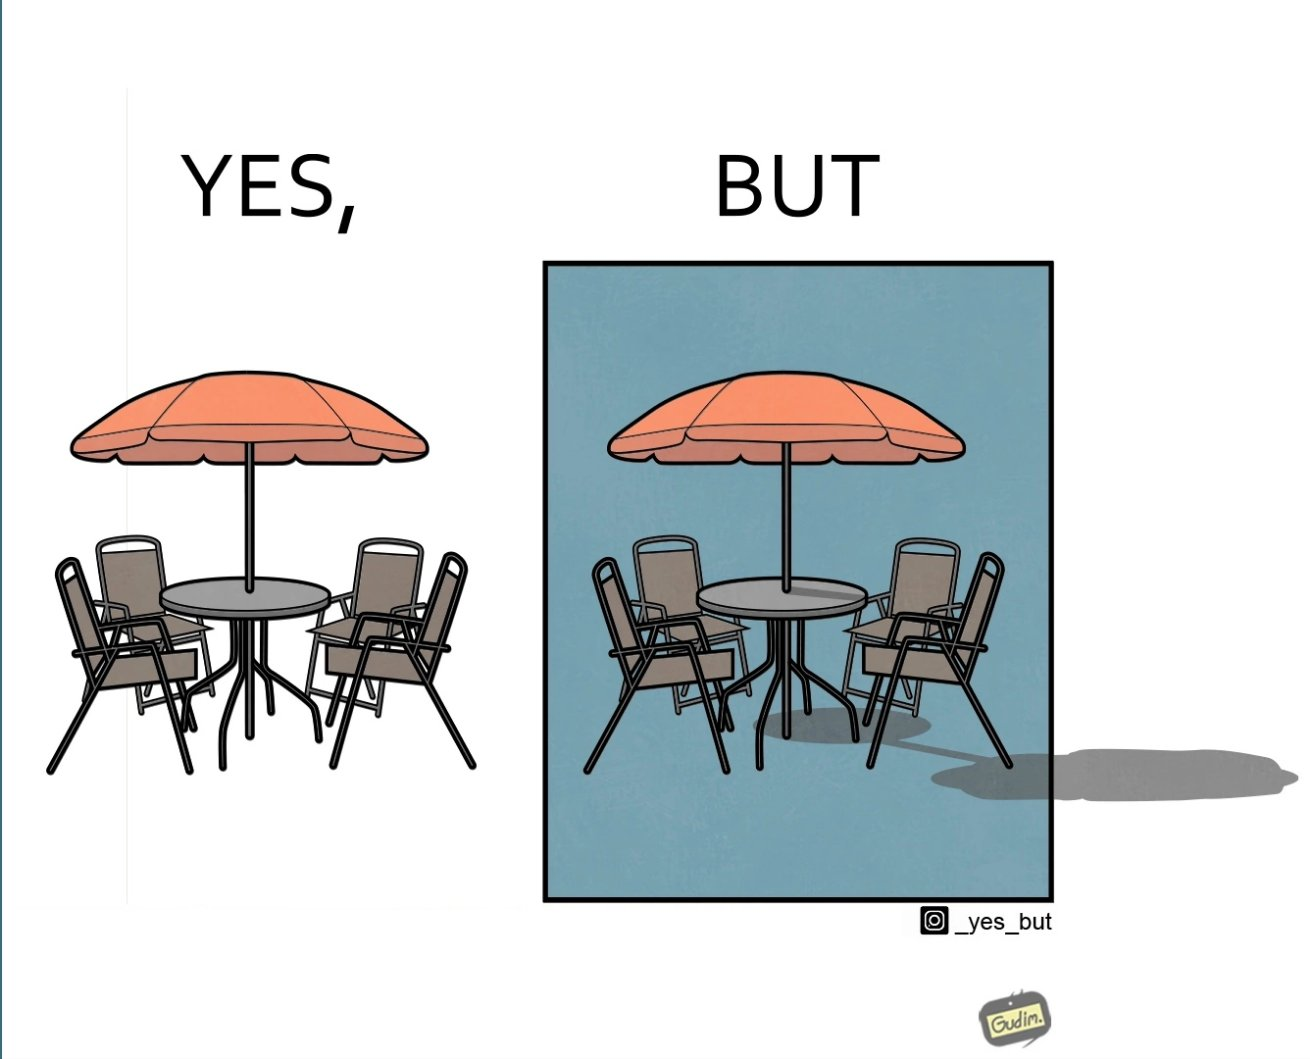Explain the humor or irony in this image. The image is ironical, as the umbrella is meant to provide shadow in the area where the chairs are present, but due to the orientation of the rays of the sun, all the chairs are in sunlight, and the umbrella is of no use in this situation. 